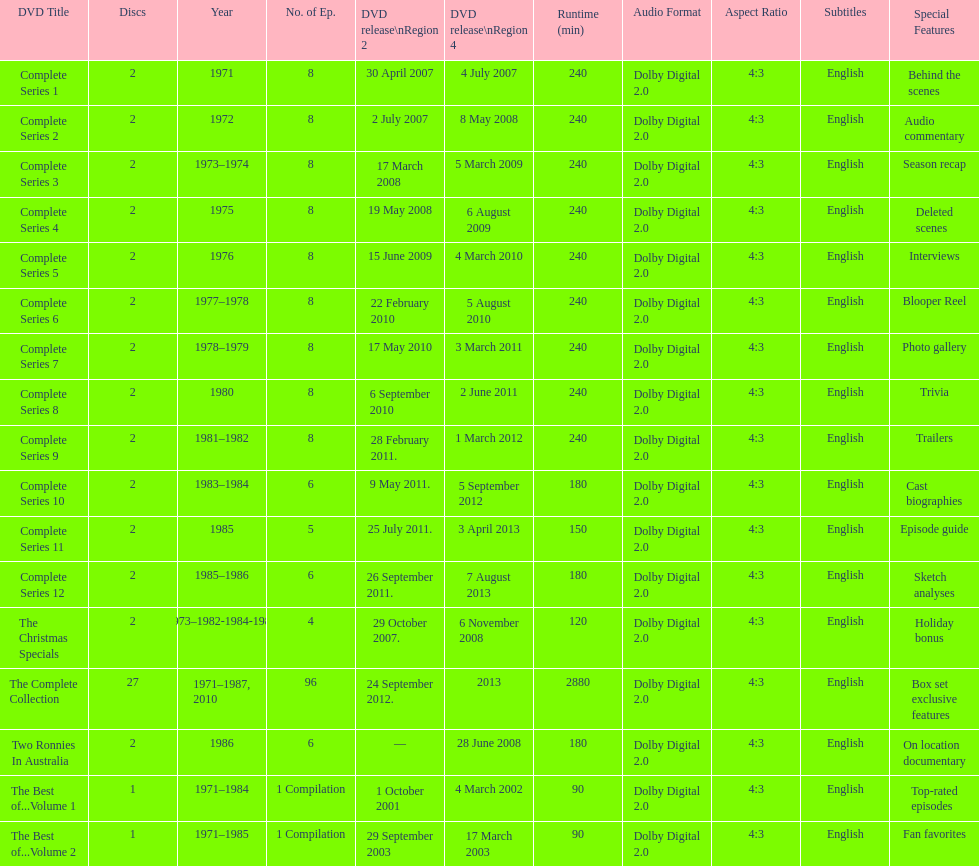The television show "the two ronnies" ran for a total of how many seasons? 12. 